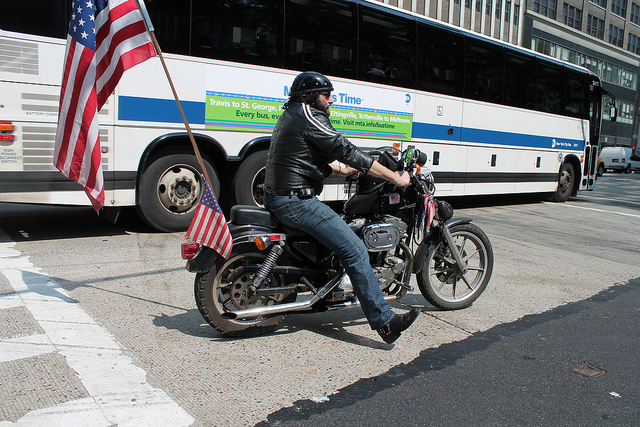Please extract the text content from this image. Time 5L George Every 